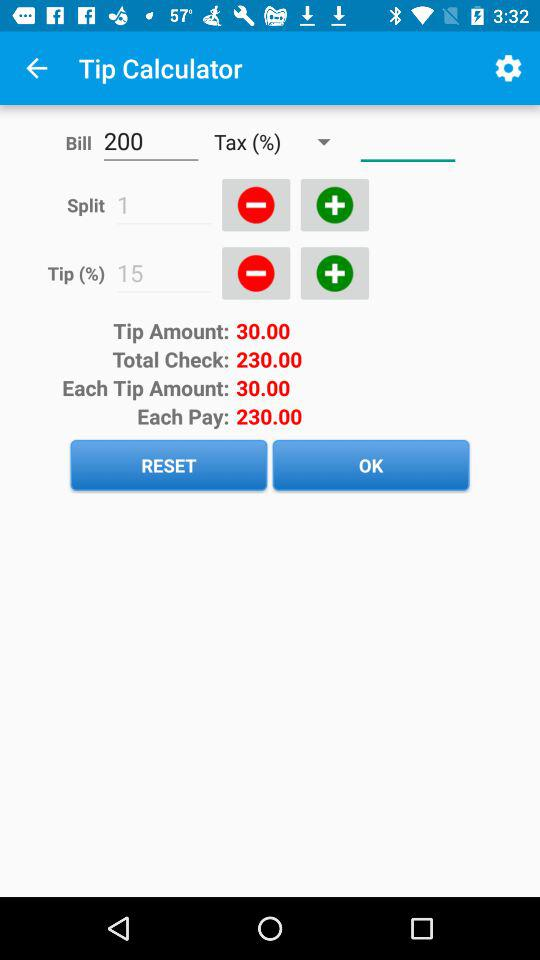What is the total check amount? The total check amount is 230.00. 